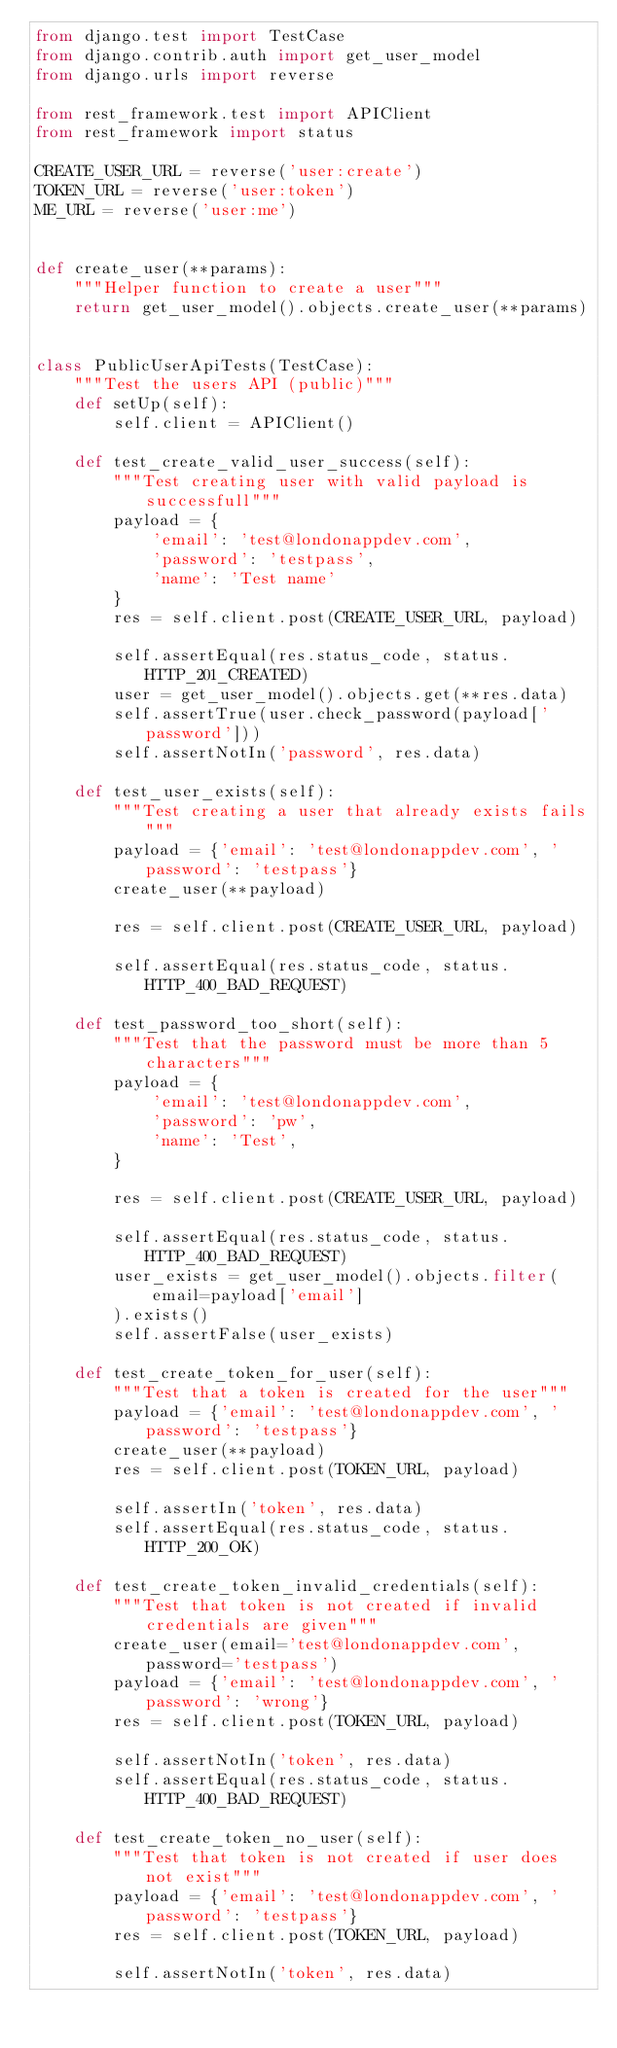<code> <loc_0><loc_0><loc_500><loc_500><_Python_>from django.test import TestCase
from django.contrib.auth import get_user_model
from django.urls import reverse

from rest_framework.test import APIClient
from rest_framework import status

CREATE_USER_URL = reverse('user:create')
TOKEN_URL = reverse('user:token')
ME_URL = reverse('user:me')


def create_user(**params):
    """Helper function to create a user"""
    return get_user_model().objects.create_user(**params)


class PublicUserApiTests(TestCase):
    """Test the users API (public)"""
    def setUp(self):
        self.client = APIClient()

    def test_create_valid_user_success(self):
        """Test creating user with valid payload is successfull"""
        payload = {
            'email': 'test@londonappdev.com',
            'password': 'testpass',
            'name': 'Test name'
        }
        res = self.client.post(CREATE_USER_URL, payload)

        self.assertEqual(res.status_code, status.HTTP_201_CREATED)
        user = get_user_model().objects.get(**res.data)
        self.assertTrue(user.check_password(payload['password']))
        self.assertNotIn('password', res.data)

    def test_user_exists(self):
        """Test creating a user that already exists fails"""
        payload = {'email': 'test@londonappdev.com', 'password': 'testpass'}
        create_user(**payload)

        res = self.client.post(CREATE_USER_URL, payload)

        self.assertEqual(res.status_code, status.HTTP_400_BAD_REQUEST)

    def test_password_too_short(self):
        """Test that the password must be more than 5 characters"""
        payload = {
            'email': 'test@londonappdev.com',
            'password': 'pw',
            'name': 'Test',
        }

        res = self.client.post(CREATE_USER_URL, payload)

        self.assertEqual(res.status_code, status.HTTP_400_BAD_REQUEST)
        user_exists = get_user_model().objects.filter(
            email=payload['email']
        ).exists()
        self.assertFalse(user_exists)

    def test_create_token_for_user(self):
        """Test that a token is created for the user"""
        payload = {'email': 'test@londonappdev.com', 'password': 'testpass'}
        create_user(**payload)
        res = self.client.post(TOKEN_URL, payload)

        self.assertIn('token', res.data)
        self.assertEqual(res.status_code, status.HTTP_200_OK)

    def test_create_token_invalid_credentials(self):
        """Test that token is not created if invalid credentials are given"""
        create_user(email='test@londonappdev.com', password='testpass')
        payload = {'email': 'test@londonappdev.com', 'password': 'wrong'}
        res = self.client.post(TOKEN_URL, payload)

        self.assertNotIn('token', res.data)
        self.assertEqual(res.status_code, status.HTTP_400_BAD_REQUEST)

    def test_create_token_no_user(self):
        """Test that token is not created if user does not exist"""
        payload = {'email': 'test@londonappdev.com', 'password': 'testpass'}
        res = self.client.post(TOKEN_URL, payload)

        self.assertNotIn('token', res.data)</code> 